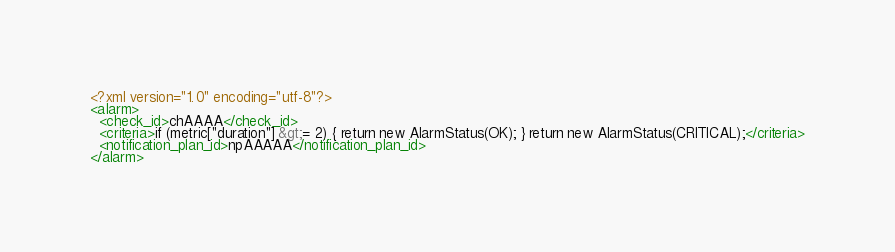Convert code to text. <code><loc_0><loc_0><loc_500><loc_500><_XML_><?xml version="1.0" encoding="utf-8"?>
<alarm>
  <check_id>chAAAA</check_id>
  <criteria>if (metric["duration"] &gt;= 2) { return new AlarmStatus(OK); } return new AlarmStatus(CRITICAL);</criteria>
  <notification_plan_id>npAAAAA</notification_plan_id>
</alarm>
</code> 